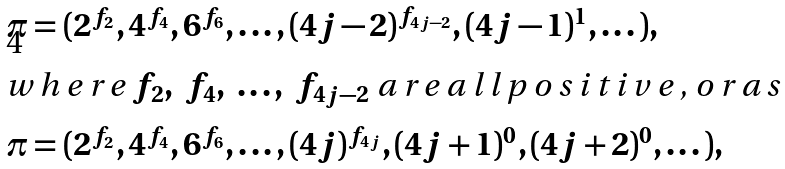Convert formula to latex. <formula><loc_0><loc_0><loc_500><loc_500>\pi & = ( 2 ^ { f _ { 2 } } , 4 ^ { f _ { 4 } } , 6 ^ { f _ { 6 } } , \dots , ( 4 j - 2 ) ^ { f _ { 4 j - 2 } } , ( 4 j - 1 ) ^ { 1 } , \dots ) , \\ \intertext { w h e r e $ f _ { 2 } , \ f _ { 4 } , \ \dots , \ f _ { 4 j - 2 } $ a r e a l l p o s i t i v e , o r a s } \pi & = ( 2 ^ { f _ { 2 } } , 4 ^ { f _ { 4 } } , 6 ^ { f _ { 6 } } , \dots , ( 4 j ) ^ { f _ { 4 j } } , ( 4 j + 1 ) ^ { 0 } , ( 4 j + 2 ) ^ { 0 } , \dots ) ,</formula> 